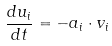Convert formula to latex. <formula><loc_0><loc_0><loc_500><loc_500>\frac { d u _ { i } } { d t } = - a _ { i } \cdot v _ { i }</formula> 